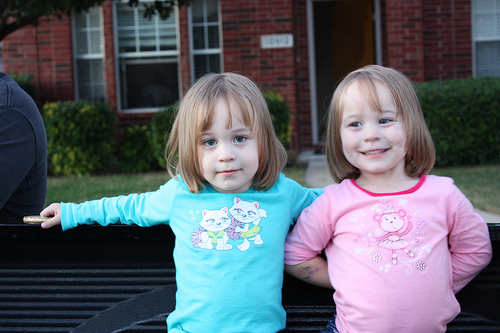<image>
Is the head above the tshirt? Yes. The head is positioned above the tshirt in the vertical space, higher up in the scene. 